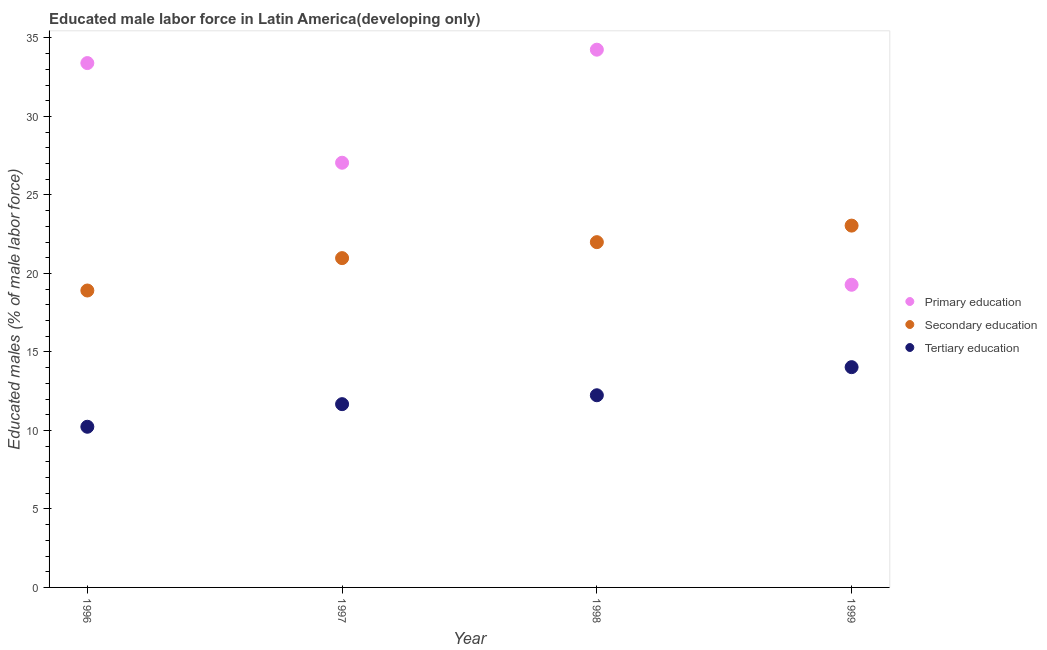How many different coloured dotlines are there?
Ensure brevity in your answer.  3. Is the number of dotlines equal to the number of legend labels?
Keep it short and to the point. Yes. What is the percentage of male labor force who received secondary education in 1999?
Give a very brief answer. 23.05. Across all years, what is the maximum percentage of male labor force who received tertiary education?
Make the answer very short. 14.03. Across all years, what is the minimum percentage of male labor force who received secondary education?
Offer a very short reply. 18.91. In which year was the percentage of male labor force who received tertiary education maximum?
Provide a succinct answer. 1999. In which year was the percentage of male labor force who received tertiary education minimum?
Your answer should be very brief. 1996. What is the total percentage of male labor force who received primary education in the graph?
Offer a very short reply. 113.99. What is the difference between the percentage of male labor force who received primary education in 1997 and that in 1999?
Your answer should be compact. 7.77. What is the difference between the percentage of male labor force who received tertiary education in 1997 and the percentage of male labor force who received primary education in 1999?
Offer a terse response. -7.6. What is the average percentage of male labor force who received secondary education per year?
Offer a very short reply. 21.23. In the year 1999, what is the difference between the percentage of male labor force who received secondary education and percentage of male labor force who received tertiary education?
Offer a terse response. 9.02. What is the ratio of the percentage of male labor force who received secondary education in 1997 to that in 1998?
Your answer should be very brief. 0.95. What is the difference between the highest and the second highest percentage of male labor force who received primary education?
Your response must be concise. 0.85. What is the difference between the highest and the lowest percentage of male labor force who received secondary education?
Offer a very short reply. 4.13. Is it the case that in every year, the sum of the percentage of male labor force who received primary education and percentage of male labor force who received secondary education is greater than the percentage of male labor force who received tertiary education?
Your answer should be very brief. Yes. Does the percentage of male labor force who received tertiary education monotonically increase over the years?
Provide a succinct answer. Yes. Is the percentage of male labor force who received tertiary education strictly greater than the percentage of male labor force who received primary education over the years?
Provide a succinct answer. No. How many years are there in the graph?
Make the answer very short. 4. What is the difference between two consecutive major ticks on the Y-axis?
Your response must be concise. 5. Are the values on the major ticks of Y-axis written in scientific E-notation?
Ensure brevity in your answer.  No. Does the graph contain any zero values?
Your response must be concise. No. Where does the legend appear in the graph?
Your answer should be very brief. Center right. How many legend labels are there?
Provide a short and direct response. 3. How are the legend labels stacked?
Your response must be concise. Vertical. What is the title of the graph?
Keep it short and to the point. Educated male labor force in Latin America(developing only). Does "Transport equipments" appear as one of the legend labels in the graph?
Your answer should be very brief. No. What is the label or title of the Y-axis?
Provide a short and direct response. Educated males (% of male labor force). What is the Educated males (% of male labor force) in Primary education in 1996?
Your answer should be compact. 33.4. What is the Educated males (% of male labor force) in Secondary education in 1996?
Offer a very short reply. 18.91. What is the Educated males (% of male labor force) of Tertiary education in 1996?
Give a very brief answer. 10.23. What is the Educated males (% of male labor force) of Primary education in 1997?
Make the answer very short. 27.05. What is the Educated males (% of male labor force) in Secondary education in 1997?
Offer a very short reply. 20.98. What is the Educated males (% of male labor force) of Tertiary education in 1997?
Make the answer very short. 11.67. What is the Educated males (% of male labor force) in Primary education in 1998?
Provide a short and direct response. 34.25. What is the Educated males (% of male labor force) of Secondary education in 1998?
Offer a terse response. 21.99. What is the Educated males (% of male labor force) in Tertiary education in 1998?
Provide a succinct answer. 12.24. What is the Educated males (% of male labor force) of Primary education in 1999?
Offer a terse response. 19.28. What is the Educated males (% of male labor force) of Secondary education in 1999?
Offer a terse response. 23.05. What is the Educated males (% of male labor force) of Tertiary education in 1999?
Offer a very short reply. 14.03. Across all years, what is the maximum Educated males (% of male labor force) of Primary education?
Give a very brief answer. 34.25. Across all years, what is the maximum Educated males (% of male labor force) of Secondary education?
Provide a short and direct response. 23.05. Across all years, what is the maximum Educated males (% of male labor force) of Tertiary education?
Your answer should be very brief. 14.03. Across all years, what is the minimum Educated males (% of male labor force) of Primary education?
Your response must be concise. 19.28. Across all years, what is the minimum Educated males (% of male labor force) in Secondary education?
Ensure brevity in your answer.  18.91. Across all years, what is the minimum Educated males (% of male labor force) of Tertiary education?
Your answer should be very brief. 10.23. What is the total Educated males (% of male labor force) of Primary education in the graph?
Your response must be concise. 113.99. What is the total Educated males (% of male labor force) in Secondary education in the graph?
Make the answer very short. 84.93. What is the total Educated males (% of male labor force) in Tertiary education in the graph?
Ensure brevity in your answer.  48.18. What is the difference between the Educated males (% of male labor force) in Primary education in 1996 and that in 1997?
Ensure brevity in your answer.  6.35. What is the difference between the Educated males (% of male labor force) of Secondary education in 1996 and that in 1997?
Your answer should be compact. -2.06. What is the difference between the Educated males (% of male labor force) in Tertiary education in 1996 and that in 1997?
Your answer should be very brief. -1.44. What is the difference between the Educated males (% of male labor force) in Primary education in 1996 and that in 1998?
Ensure brevity in your answer.  -0.85. What is the difference between the Educated males (% of male labor force) of Secondary education in 1996 and that in 1998?
Keep it short and to the point. -3.08. What is the difference between the Educated males (% of male labor force) in Tertiary education in 1996 and that in 1998?
Your response must be concise. -2.01. What is the difference between the Educated males (% of male labor force) in Primary education in 1996 and that in 1999?
Ensure brevity in your answer.  14.12. What is the difference between the Educated males (% of male labor force) of Secondary education in 1996 and that in 1999?
Offer a very short reply. -4.13. What is the difference between the Educated males (% of male labor force) in Tertiary education in 1996 and that in 1999?
Make the answer very short. -3.8. What is the difference between the Educated males (% of male labor force) of Primary education in 1997 and that in 1998?
Give a very brief answer. -7.2. What is the difference between the Educated males (% of male labor force) of Secondary education in 1997 and that in 1998?
Ensure brevity in your answer.  -1.02. What is the difference between the Educated males (% of male labor force) in Tertiary education in 1997 and that in 1998?
Make the answer very short. -0.57. What is the difference between the Educated males (% of male labor force) in Primary education in 1997 and that in 1999?
Make the answer very short. 7.77. What is the difference between the Educated males (% of male labor force) in Secondary education in 1997 and that in 1999?
Your response must be concise. -2.07. What is the difference between the Educated males (% of male labor force) in Tertiary education in 1997 and that in 1999?
Keep it short and to the point. -2.36. What is the difference between the Educated males (% of male labor force) of Primary education in 1998 and that in 1999?
Your answer should be compact. 14.97. What is the difference between the Educated males (% of male labor force) of Secondary education in 1998 and that in 1999?
Provide a succinct answer. -1.05. What is the difference between the Educated males (% of male labor force) of Tertiary education in 1998 and that in 1999?
Make the answer very short. -1.79. What is the difference between the Educated males (% of male labor force) of Primary education in 1996 and the Educated males (% of male labor force) of Secondary education in 1997?
Make the answer very short. 12.42. What is the difference between the Educated males (% of male labor force) in Primary education in 1996 and the Educated males (% of male labor force) in Tertiary education in 1997?
Offer a very short reply. 21.73. What is the difference between the Educated males (% of male labor force) of Secondary education in 1996 and the Educated males (% of male labor force) of Tertiary education in 1997?
Your response must be concise. 7.24. What is the difference between the Educated males (% of male labor force) in Primary education in 1996 and the Educated males (% of male labor force) in Secondary education in 1998?
Your response must be concise. 11.41. What is the difference between the Educated males (% of male labor force) of Primary education in 1996 and the Educated males (% of male labor force) of Tertiary education in 1998?
Your answer should be very brief. 21.16. What is the difference between the Educated males (% of male labor force) in Secondary education in 1996 and the Educated males (% of male labor force) in Tertiary education in 1998?
Make the answer very short. 6.67. What is the difference between the Educated males (% of male labor force) in Primary education in 1996 and the Educated males (% of male labor force) in Secondary education in 1999?
Your answer should be very brief. 10.35. What is the difference between the Educated males (% of male labor force) of Primary education in 1996 and the Educated males (% of male labor force) of Tertiary education in 1999?
Offer a very short reply. 19.37. What is the difference between the Educated males (% of male labor force) of Secondary education in 1996 and the Educated males (% of male labor force) of Tertiary education in 1999?
Ensure brevity in your answer.  4.88. What is the difference between the Educated males (% of male labor force) of Primary education in 1997 and the Educated males (% of male labor force) of Secondary education in 1998?
Your answer should be compact. 5.06. What is the difference between the Educated males (% of male labor force) of Primary education in 1997 and the Educated males (% of male labor force) of Tertiary education in 1998?
Offer a terse response. 14.81. What is the difference between the Educated males (% of male labor force) in Secondary education in 1997 and the Educated males (% of male labor force) in Tertiary education in 1998?
Your response must be concise. 8.74. What is the difference between the Educated males (% of male labor force) in Primary education in 1997 and the Educated males (% of male labor force) in Secondary education in 1999?
Offer a terse response. 4.01. What is the difference between the Educated males (% of male labor force) of Primary education in 1997 and the Educated males (% of male labor force) of Tertiary education in 1999?
Your answer should be very brief. 13.02. What is the difference between the Educated males (% of male labor force) of Secondary education in 1997 and the Educated males (% of male labor force) of Tertiary education in 1999?
Offer a terse response. 6.95. What is the difference between the Educated males (% of male labor force) in Primary education in 1998 and the Educated males (% of male labor force) in Secondary education in 1999?
Your response must be concise. 11.21. What is the difference between the Educated males (% of male labor force) in Primary education in 1998 and the Educated males (% of male labor force) in Tertiary education in 1999?
Your answer should be compact. 20.22. What is the difference between the Educated males (% of male labor force) of Secondary education in 1998 and the Educated males (% of male labor force) of Tertiary education in 1999?
Your answer should be compact. 7.96. What is the average Educated males (% of male labor force) in Primary education per year?
Ensure brevity in your answer.  28.5. What is the average Educated males (% of male labor force) of Secondary education per year?
Ensure brevity in your answer.  21.23. What is the average Educated males (% of male labor force) in Tertiary education per year?
Provide a short and direct response. 12.05. In the year 1996, what is the difference between the Educated males (% of male labor force) in Primary education and Educated males (% of male labor force) in Secondary education?
Make the answer very short. 14.49. In the year 1996, what is the difference between the Educated males (% of male labor force) in Primary education and Educated males (% of male labor force) in Tertiary education?
Provide a short and direct response. 23.17. In the year 1996, what is the difference between the Educated males (% of male labor force) of Secondary education and Educated males (% of male labor force) of Tertiary education?
Keep it short and to the point. 8.68. In the year 1997, what is the difference between the Educated males (% of male labor force) in Primary education and Educated males (% of male labor force) in Secondary education?
Provide a succinct answer. 6.08. In the year 1997, what is the difference between the Educated males (% of male labor force) in Primary education and Educated males (% of male labor force) in Tertiary education?
Your answer should be very brief. 15.38. In the year 1997, what is the difference between the Educated males (% of male labor force) in Secondary education and Educated males (% of male labor force) in Tertiary education?
Make the answer very short. 9.3. In the year 1998, what is the difference between the Educated males (% of male labor force) of Primary education and Educated males (% of male labor force) of Secondary education?
Provide a succinct answer. 12.26. In the year 1998, what is the difference between the Educated males (% of male labor force) in Primary education and Educated males (% of male labor force) in Tertiary education?
Provide a succinct answer. 22.01. In the year 1998, what is the difference between the Educated males (% of male labor force) of Secondary education and Educated males (% of male labor force) of Tertiary education?
Give a very brief answer. 9.75. In the year 1999, what is the difference between the Educated males (% of male labor force) in Primary education and Educated males (% of male labor force) in Secondary education?
Your answer should be compact. -3.77. In the year 1999, what is the difference between the Educated males (% of male labor force) in Primary education and Educated males (% of male labor force) in Tertiary education?
Provide a short and direct response. 5.25. In the year 1999, what is the difference between the Educated males (% of male labor force) in Secondary education and Educated males (% of male labor force) in Tertiary education?
Keep it short and to the point. 9.02. What is the ratio of the Educated males (% of male labor force) of Primary education in 1996 to that in 1997?
Your response must be concise. 1.23. What is the ratio of the Educated males (% of male labor force) of Secondary education in 1996 to that in 1997?
Provide a succinct answer. 0.9. What is the ratio of the Educated males (% of male labor force) of Tertiary education in 1996 to that in 1997?
Provide a succinct answer. 0.88. What is the ratio of the Educated males (% of male labor force) in Primary education in 1996 to that in 1998?
Your answer should be compact. 0.98. What is the ratio of the Educated males (% of male labor force) in Secondary education in 1996 to that in 1998?
Your answer should be compact. 0.86. What is the ratio of the Educated males (% of male labor force) in Tertiary education in 1996 to that in 1998?
Your answer should be compact. 0.84. What is the ratio of the Educated males (% of male labor force) in Primary education in 1996 to that in 1999?
Offer a terse response. 1.73. What is the ratio of the Educated males (% of male labor force) in Secondary education in 1996 to that in 1999?
Offer a very short reply. 0.82. What is the ratio of the Educated males (% of male labor force) of Tertiary education in 1996 to that in 1999?
Provide a succinct answer. 0.73. What is the ratio of the Educated males (% of male labor force) of Primary education in 1997 to that in 1998?
Provide a short and direct response. 0.79. What is the ratio of the Educated males (% of male labor force) in Secondary education in 1997 to that in 1998?
Make the answer very short. 0.95. What is the ratio of the Educated males (% of male labor force) in Tertiary education in 1997 to that in 1998?
Offer a very short reply. 0.95. What is the ratio of the Educated males (% of male labor force) in Primary education in 1997 to that in 1999?
Offer a very short reply. 1.4. What is the ratio of the Educated males (% of male labor force) of Secondary education in 1997 to that in 1999?
Your answer should be compact. 0.91. What is the ratio of the Educated males (% of male labor force) in Tertiary education in 1997 to that in 1999?
Ensure brevity in your answer.  0.83. What is the ratio of the Educated males (% of male labor force) of Primary education in 1998 to that in 1999?
Offer a very short reply. 1.78. What is the ratio of the Educated males (% of male labor force) of Secondary education in 1998 to that in 1999?
Provide a succinct answer. 0.95. What is the ratio of the Educated males (% of male labor force) in Tertiary education in 1998 to that in 1999?
Your answer should be very brief. 0.87. What is the difference between the highest and the second highest Educated males (% of male labor force) in Primary education?
Give a very brief answer. 0.85. What is the difference between the highest and the second highest Educated males (% of male labor force) in Secondary education?
Your answer should be very brief. 1.05. What is the difference between the highest and the second highest Educated males (% of male labor force) of Tertiary education?
Offer a terse response. 1.79. What is the difference between the highest and the lowest Educated males (% of male labor force) in Primary education?
Your answer should be very brief. 14.97. What is the difference between the highest and the lowest Educated males (% of male labor force) of Secondary education?
Offer a very short reply. 4.13. What is the difference between the highest and the lowest Educated males (% of male labor force) of Tertiary education?
Offer a terse response. 3.8. 